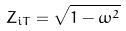<formula> <loc_0><loc_0><loc_500><loc_500>Z _ { i T } = \sqrt { 1 - \omega ^ { 2 } }</formula> 